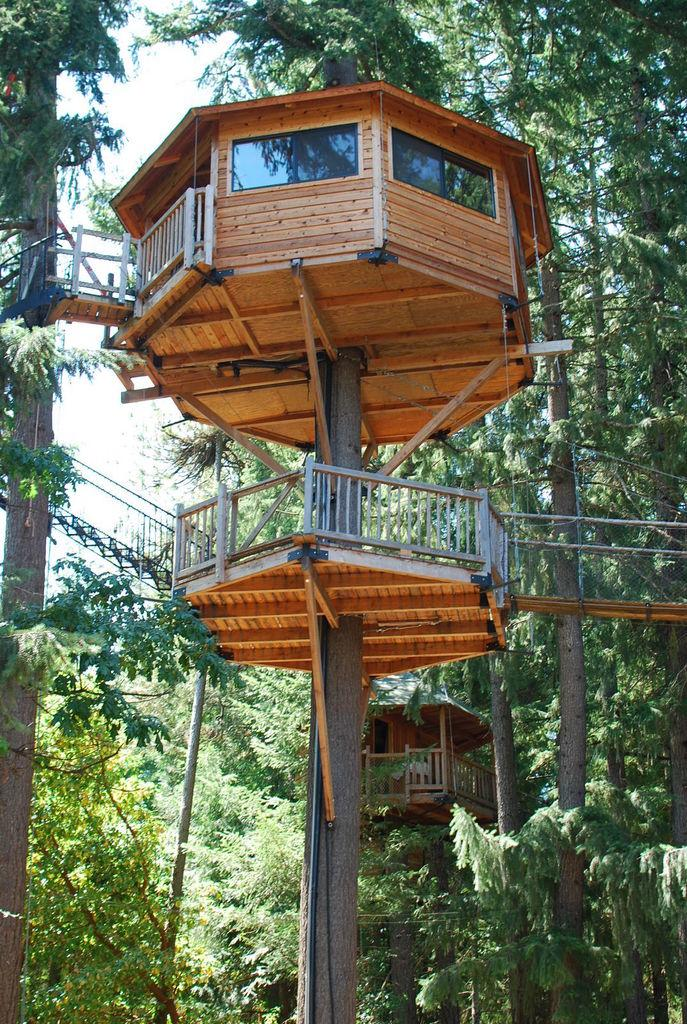What type of natural elements can be seen in the image? There are multiple trees in the image. What structures are built on the trees? There are two tree houses on the trees. What connects the trees in the image? There are bridges on both sides of the image. What can be seen in the background of the image? The sky is visible in the background of the image. How many umbrellas are open in the image? There are no umbrellas present in the image. What do the dolls believe about the tree houses in the image? There are no dolls present in the image, so their beliefs cannot be determined. 